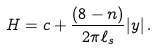<formula> <loc_0><loc_0><loc_500><loc_500>H = c + \frac { ( 8 - n ) } { 2 \pi \ell _ { s } } | y | \, .</formula> 